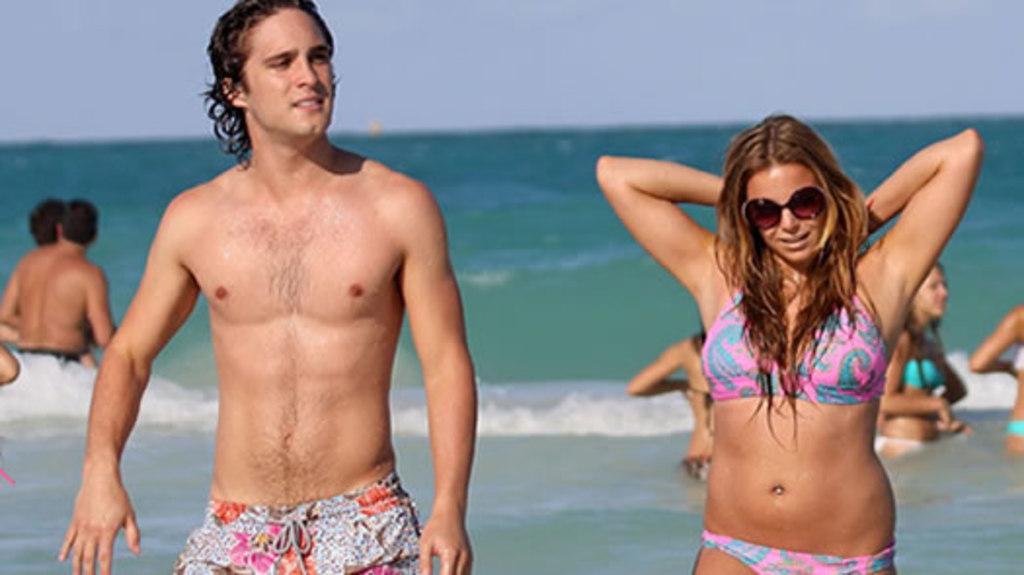How would you summarize this image in a sentence or two? Here we can see a man and a woman. She has goggles. This is water and there are few persons. In the background there is sky. 